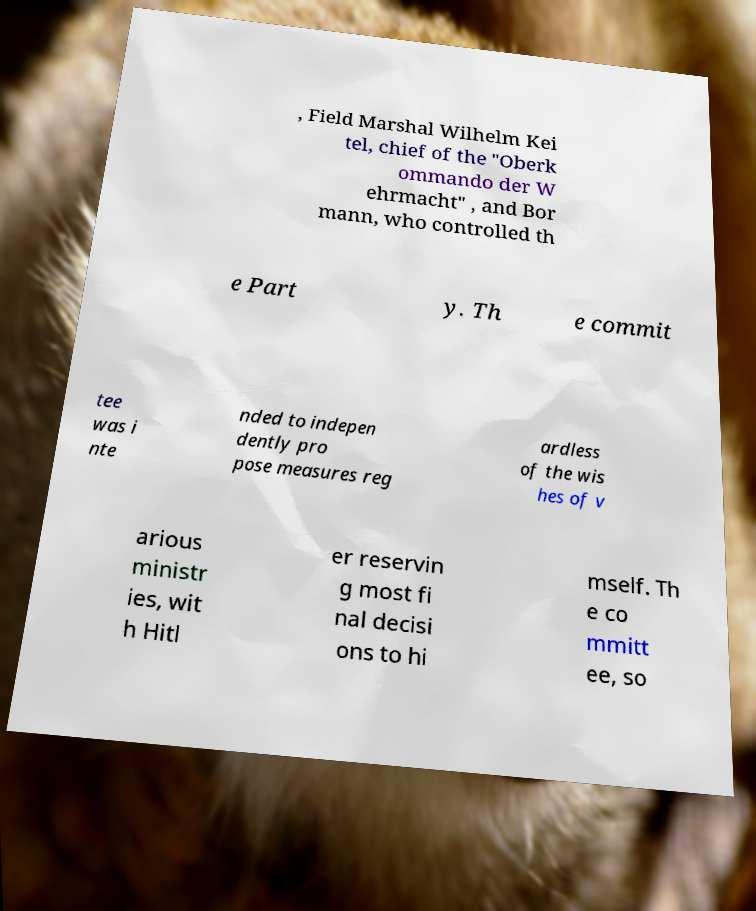For documentation purposes, I need the text within this image transcribed. Could you provide that? , Field Marshal Wilhelm Kei tel, chief of the "Oberk ommando der W ehrmacht" , and Bor mann, who controlled th e Part y. Th e commit tee was i nte nded to indepen dently pro pose measures reg ardless of the wis hes of v arious ministr ies, wit h Hitl er reservin g most fi nal decisi ons to hi mself. Th e co mmitt ee, so 